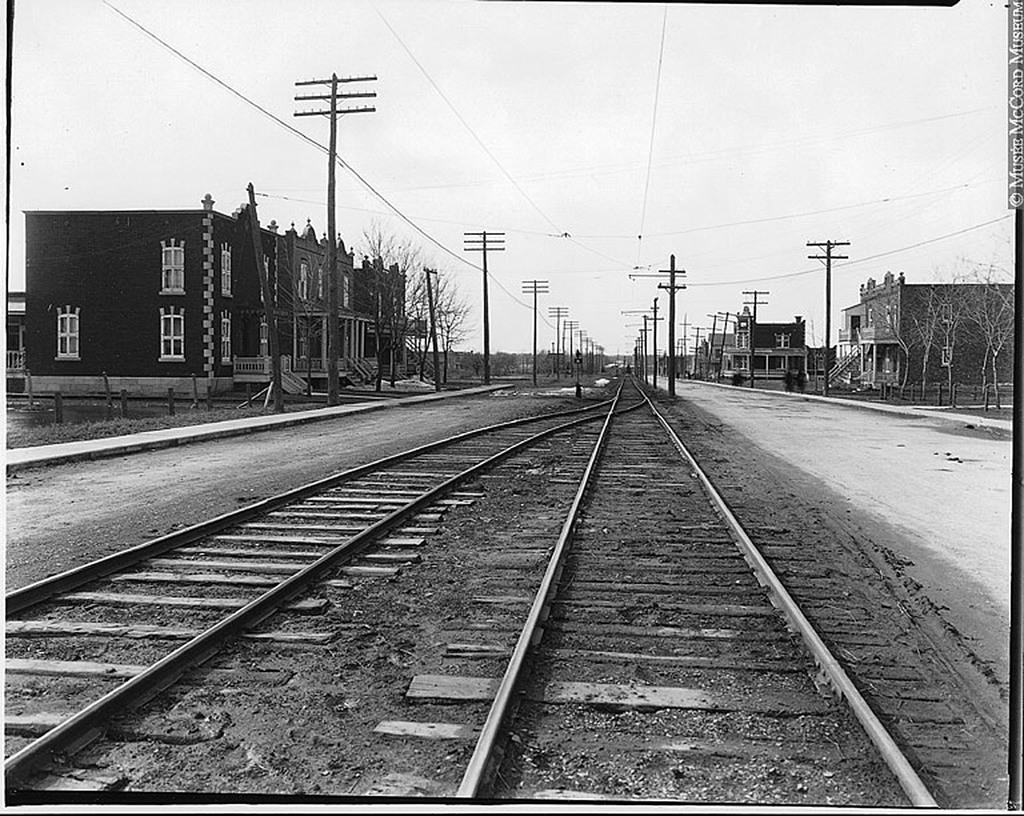What can be seen in the middle of the picture? There are two railway tracks in the middle of the picture. What is visible on either side of the picture? There are buildings on either side of the picture. What can be seen in the background of the picture? There is sky visible in the background of the picture. What type of notebook is being used by the students in the school depicted in the image? There is no school or students present in the image, and therefore no notebook can be observed. 